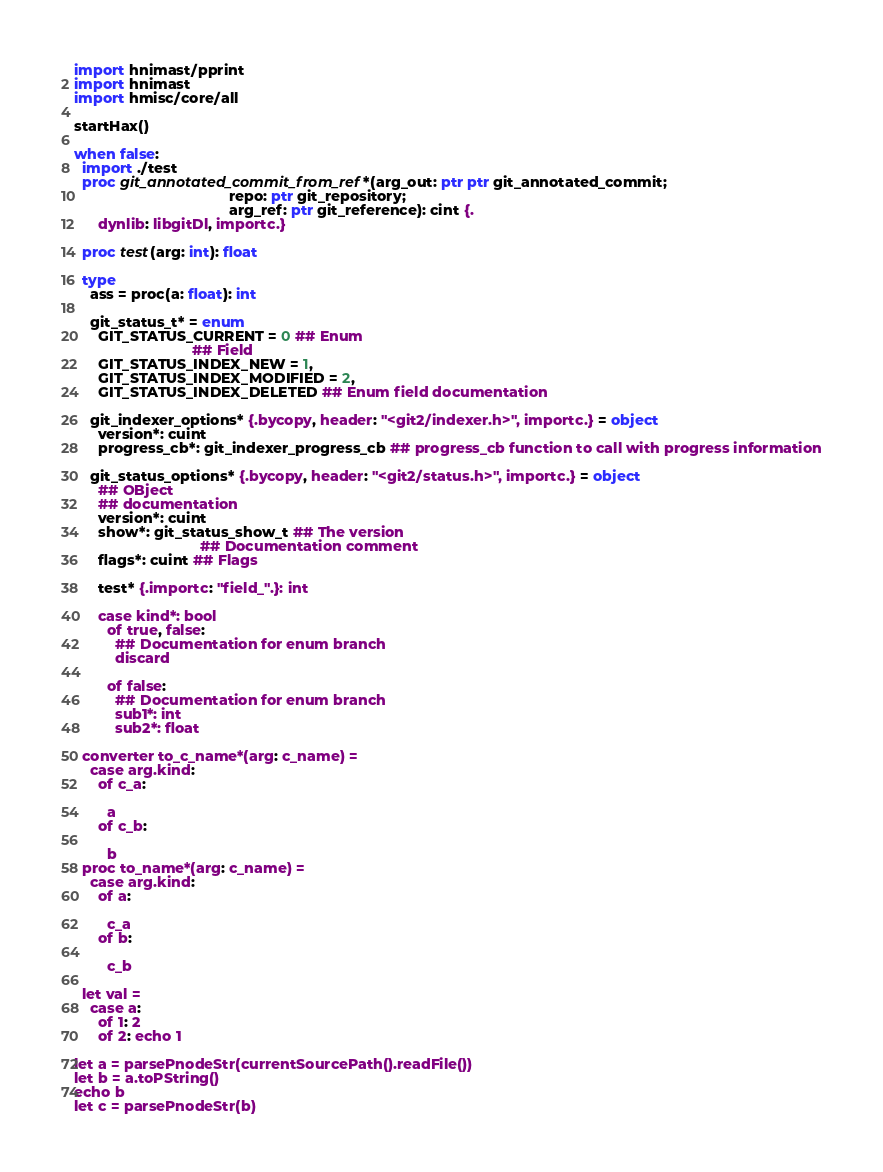<code> <loc_0><loc_0><loc_500><loc_500><_Nim_>import hnimast/pprint
import hnimast
import hmisc/core/all

startHax()

when false:
  import ./test
  proc git_annotated_commit_from_ref*(arg_out: ptr ptr git_annotated_commit;
                                      repo: ptr git_repository;
                                      arg_ref: ptr git_reference): cint {.
      dynlib: libgitDl, importc.}

  proc test(arg: int): float

  type
    ass = proc(a: float): int

    git_status_t* = enum
      GIT_STATUS_CURRENT = 0 ## Enum
                             ## Field
      GIT_STATUS_INDEX_NEW = 1,
      GIT_STATUS_INDEX_MODIFIED = 2,
      GIT_STATUS_INDEX_DELETED ## Enum field documentation

    git_indexer_options* {.bycopy, header: "<git2/indexer.h>", importc.} = object
      version*: cuint
      progress_cb*: git_indexer_progress_cb ## progress_cb function to call with progress information

    git_status_options* {.bycopy, header: "<git2/status.h>", importc.} = object
      ## OBject
      ## documentation
      version*: cuint
      show*: git_status_show_t ## The version
                               ## Documentation comment
      flags*: cuint ## Flags

      test* {.importc: "field_".}: int

      case kind*: bool
        of true, false:
          ## Documentation for enum branch
          discard

        of false:
          ## Documentation for enum branch
          sub1*: int
          sub2*: float

  converter to_c_name*(arg: c_name) =
    case arg.kind:
      of c_a:

        a
      of c_b:

        b
  proc to_name*(arg: c_name) =
    case arg.kind:
      of a:

        c_a
      of b:

        c_b

  let val =
    case a:
      of 1: 2
      of 2: echo 1

let a = parsePnodeStr(currentSourcePath().readFile())
let b = a.toPString()
echo b
let c = parsePnodeStr(b)
</code> 